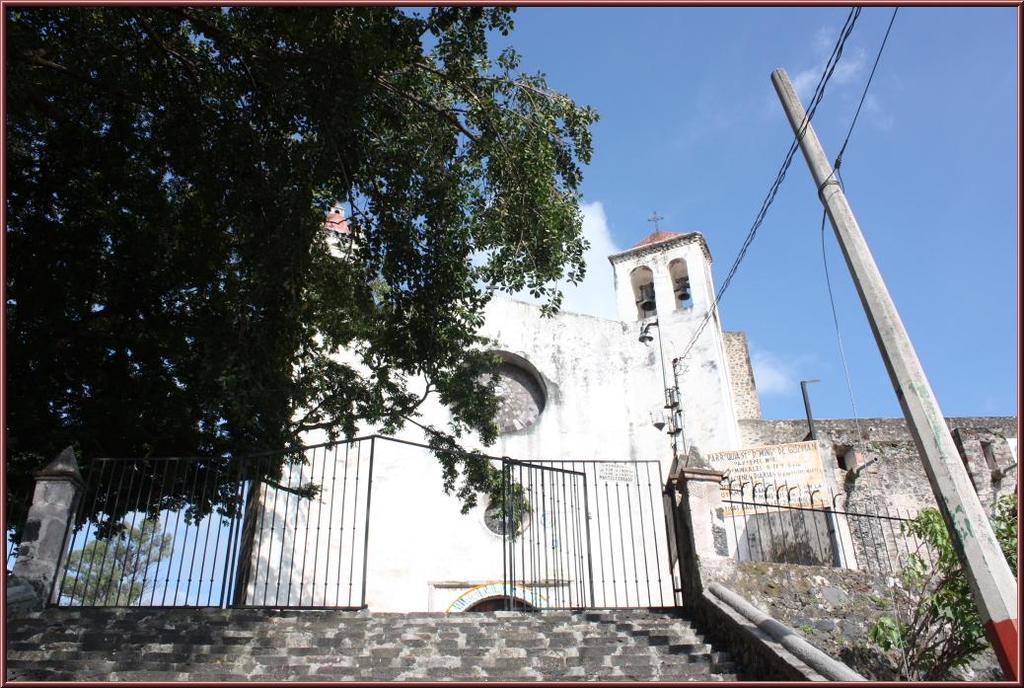Please provide a concise description of this image. In the foreground of the image we can see the steps. In the middle of the image we can see a gate, building and tree. On the top of the image we can see the pole, current wires, plus symbol and the sky. 